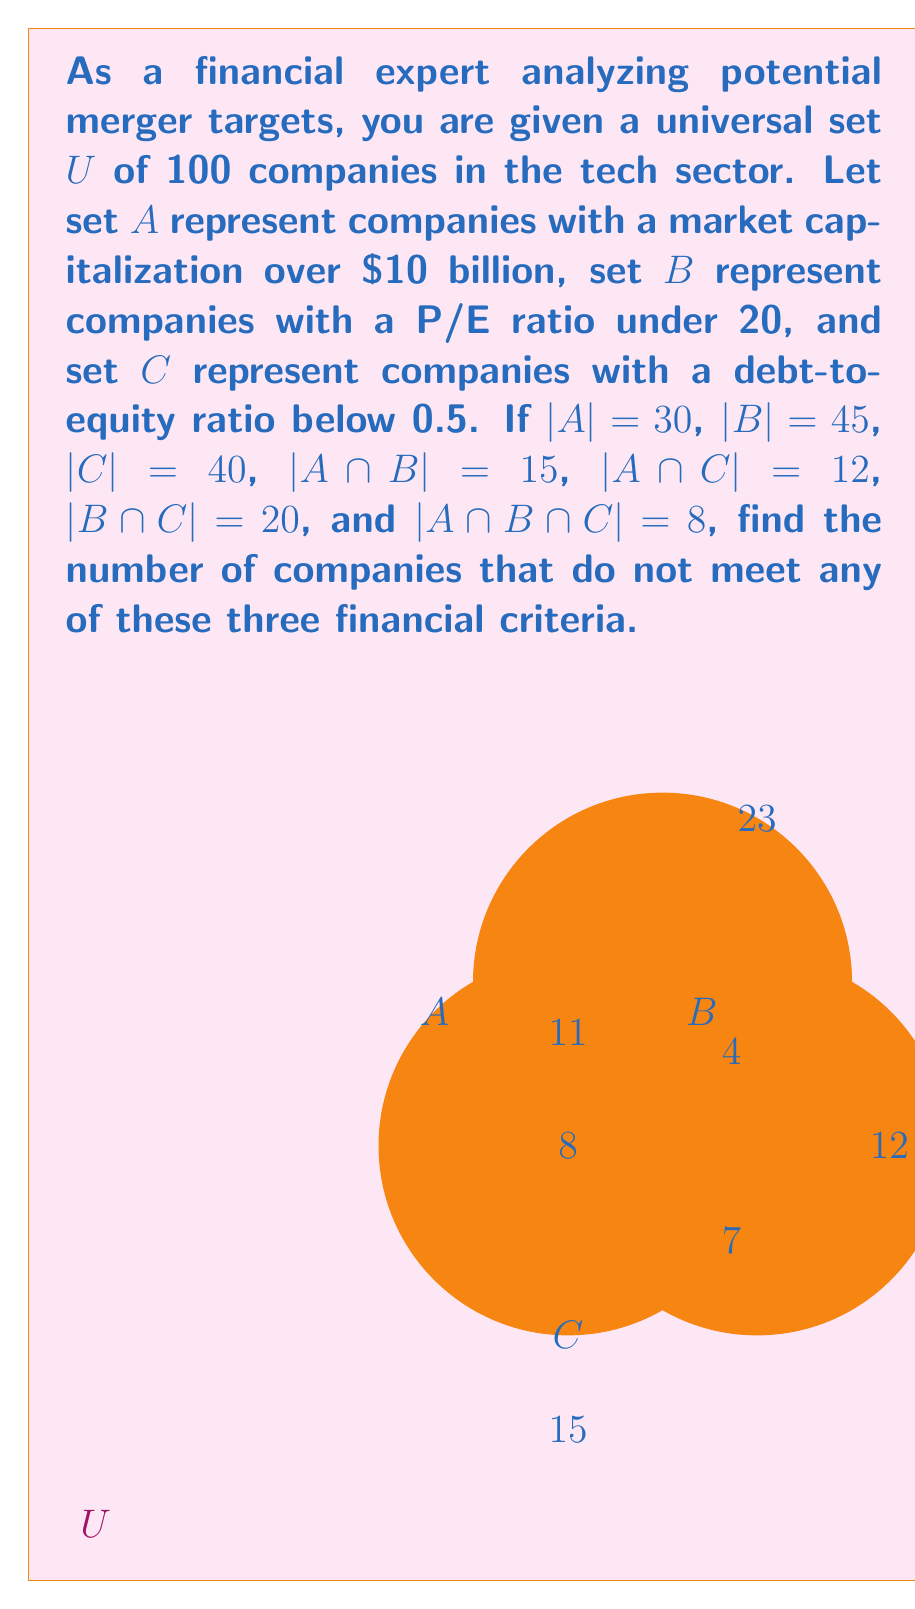Can you solve this math problem? Let's approach this step-by-step:

1) First, we need to find the number of companies that meet at least one of the criteria. This is the union of sets A, B, and C.

2) We can use the inclusion-exclusion principle to calculate this:
   $|A \cup B \cup C| = |A| + |B| + |C| - |A \cap B| - |A \cap C| - |B \cap C| + |A \cap B \cap C|$

3) Substituting the given values:
   $|A \cup B \cup C| = 30 + 45 + 40 - 15 - 12 - 20 + 8 = 76$

4) This means 76 companies meet at least one of the criteria.

5) The complement of this set (companies that don't meet any criteria) would be:
   $|U| - |A \cup B \cup C| = 100 - 76 = 24$

Therefore, 24 companies do not meet any of the three financial criteria.
Answer: 24 